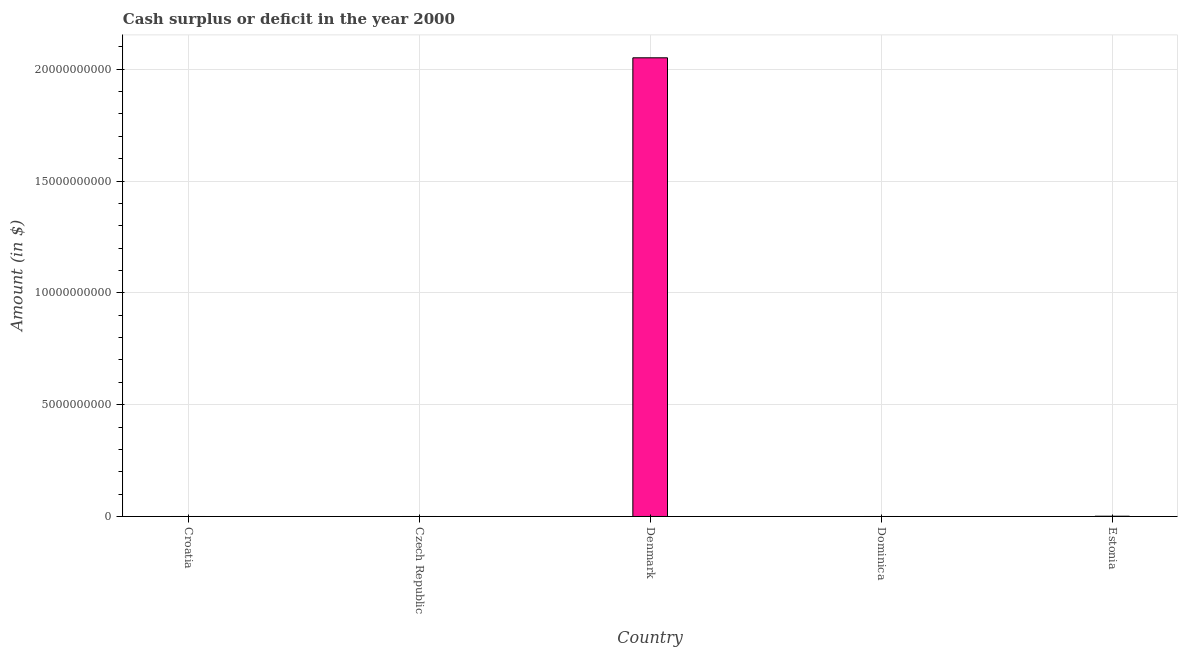Does the graph contain any zero values?
Offer a terse response. Yes. What is the title of the graph?
Your response must be concise. Cash surplus or deficit in the year 2000. What is the label or title of the Y-axis?
Your answer should be very brief. Amount (in $). What is the cash surplus or deficit in Croatia?
Provide a short and direct response. 0. Across all countries, what is the maximum cash surplus or deficit?
Provide a succinct answer. 2.05e+1. Across all countries, what is the minimum cash surplus or deficit?
Provide a succinct answer. 0. In which country was the cash surplus or deficit maximum?
Offer a terse response. Denmark. What is the sum of the cash surplus or deficit?
Keep it short and to the point. 2.05e+1. What is the difference between the cash surplus or deficit in Denmark and Estonia?
Your answer should be compact. 2.05e+1. What is the average cash surplus or deficit per country?
Make the answer very short. 4.10e+09. What is the median cash surplus or deficit?
Ensure brevity in your answer.  0. In how many countries, is the cash surplus or deficit greater than 17000000000 $?
Your answer should be very brief. 1. Is the cash surplus or deficit in Denmark less than that in Estonia?
Provide a short and direct response. No. Is the difference between the cash surplus or deficit in Denmark and Estonia greater than the difference between any two countries?
Provide a succinct answer. No. What is the difference between the highest and the lowest cash surplus or deficit?
Your answer should be compact. 2.05e+1. In how many countries, is the cash surplus or deficit greater than the average cash surplus or deficit taken over all countries?
Offer a very short reply. 1. How many bars are there?
Offer a very short reply. 2. How many countries are there in the graph?
Keep it short and to the point. 5. Are the values on the major ticks of Y-axis written in scientific E-notation?
Offer a terse response. No. What is the Amount (in $) of Croatia?
Your answer should be compact. 0. What is the Amount (in $) of Denmark?
Offer a very short reply. 2.05e+1. What is the Amount (in $) of Dominica?
Your answer should be very brief. 0. What is the Amount (in $) in Estonia?
Your answer should be compact. 1.23e+07. What is the difference between the Amount (in $) in Denmark and Estonia?
Ensure brevity in your answer.  2.05e+1. What is the ratio of the Amount (in $) in Denmark to that in Estonia?
Your answer should be compact. 1667.4. 